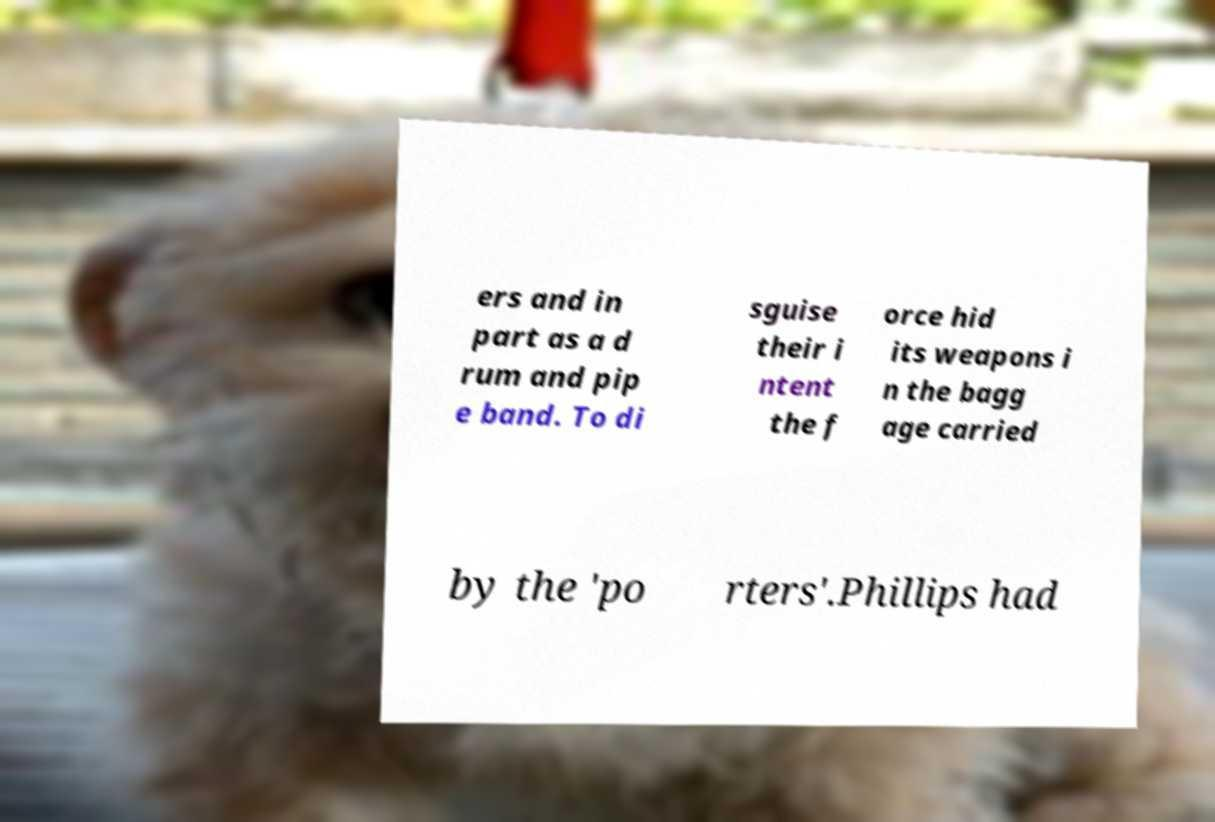Please identify and transcribe the text found in this image. ers and in part as a d rum and pip e band. To di sguise their i ntent the f orce hid its weapons i n the bagg age carried by the 'po rters'.Phillips had 